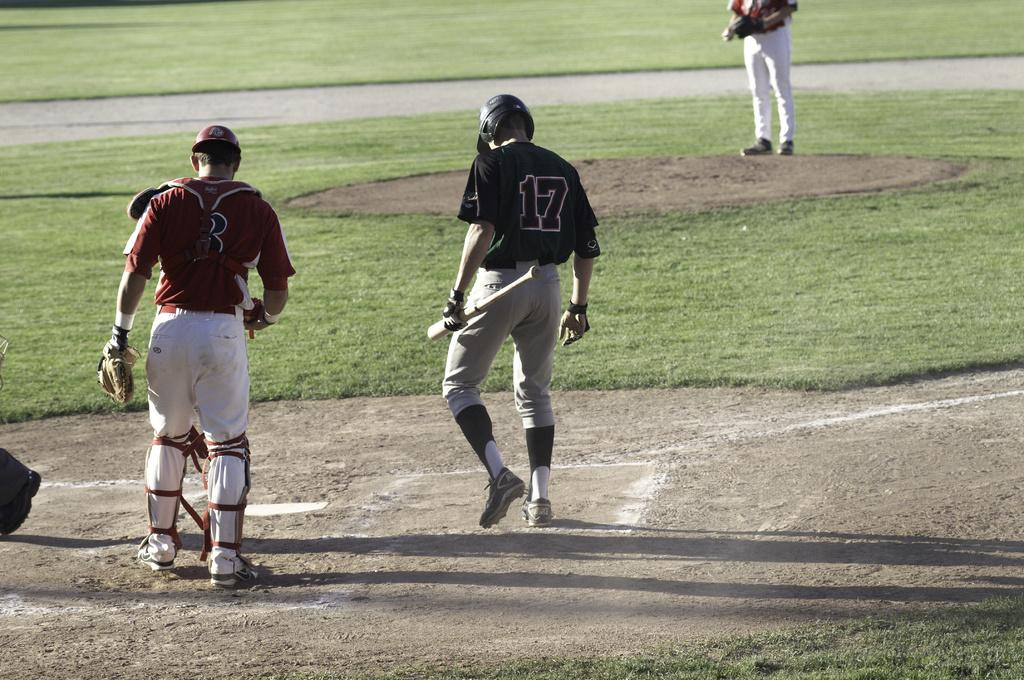Provide a one-sentence caption for the provided image. some baseball players with the hitter wearing 17. 